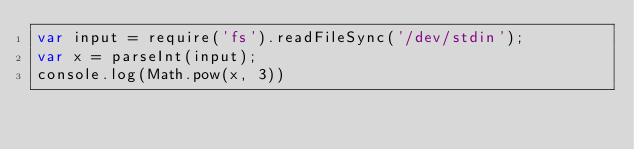Convert code to text. <code><loc_0><loc_0><loc_500><loc_500><_JavaScript_>var input = require('fs').readFileSync('/dev/stdin');
var x = parseInt(input);
console.log(Math.pow(x, 3))

</code> 